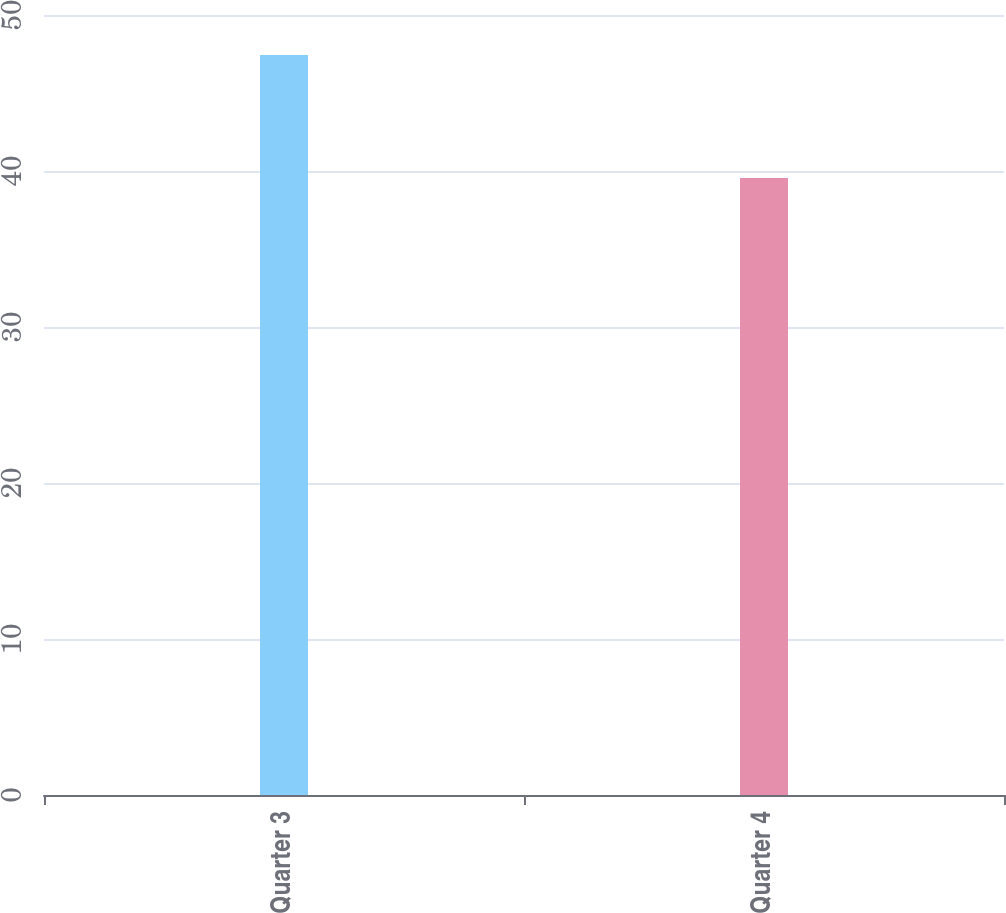Convert chart to OTSL. <chart><loc_0><loc_0><loc_500><loc_500><bar_chart><fcel>Quarter 3<fcel>Quarter 4<nl><fcel>47.43<fcel>39.55<nl></chart> 